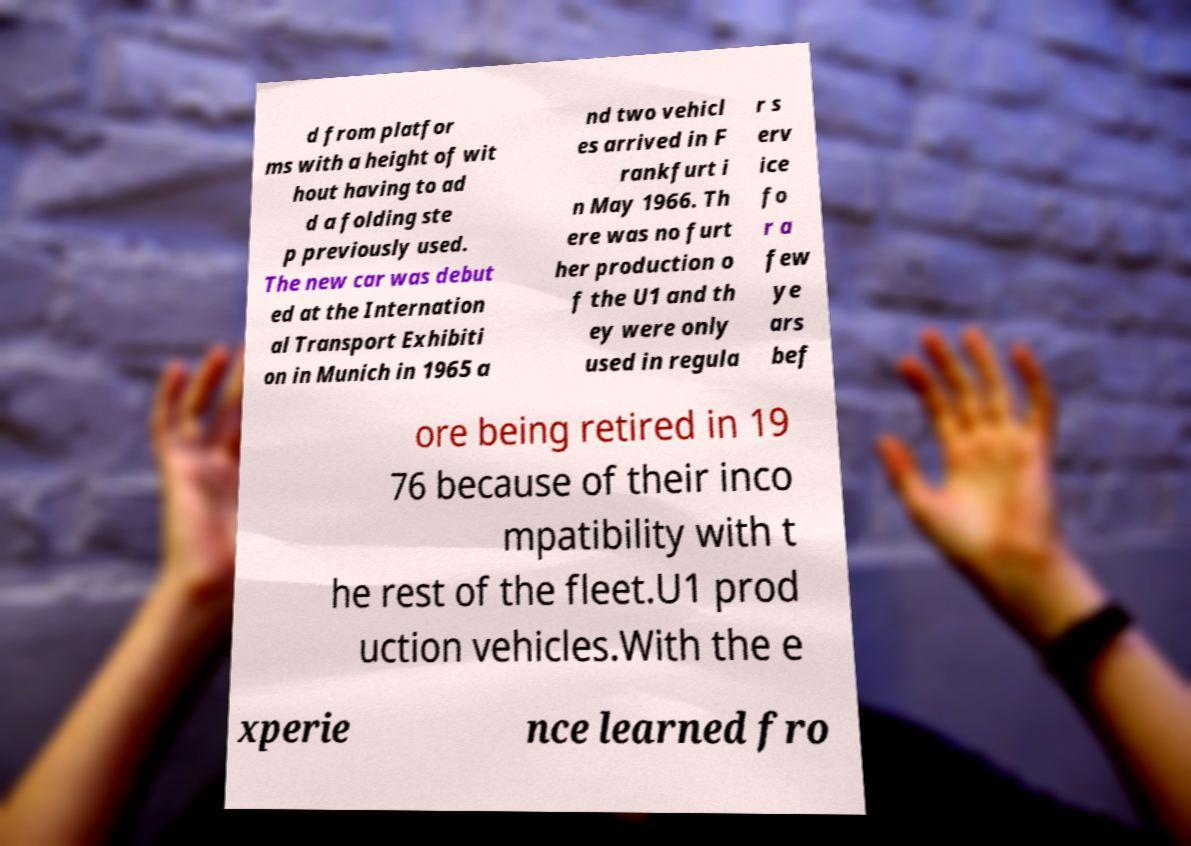For documentation purposes, I need the text within this image transcribed. Could you provide that? d from platfor ms with a height of wit hout having to ad d a folding ste p previously used. The new car was debut ed at the Internation al Transport Exhibiti on in Munich in 1965 a nd two vehicl es arrived in F rankfurt i n May 1966. Th ere was no furt her production o f the U1 and th ey were only used in regula r s erv ice fo r a few ye ars bef ore being retired in 19 76 because of their inco mpatibility with t he rest of the fleet.U1 prod uction vehicles.With the e xperie nce learned fro 